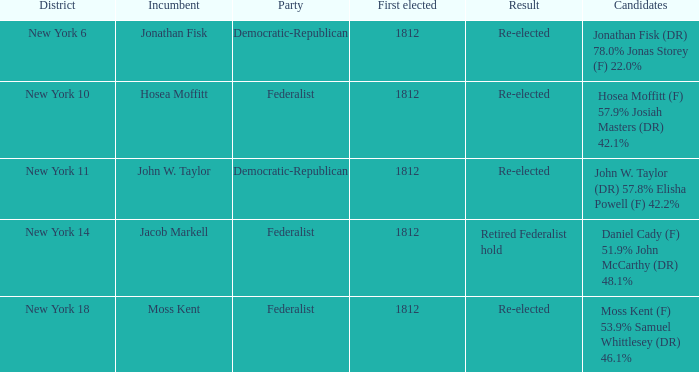Identify the current officeholder for new york's 10th district. Hosea Moffitt. 